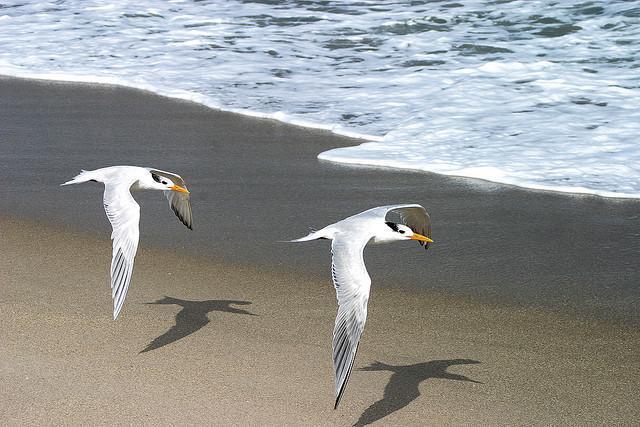How many birds can be seen?
Give a very brief answer. 2. 